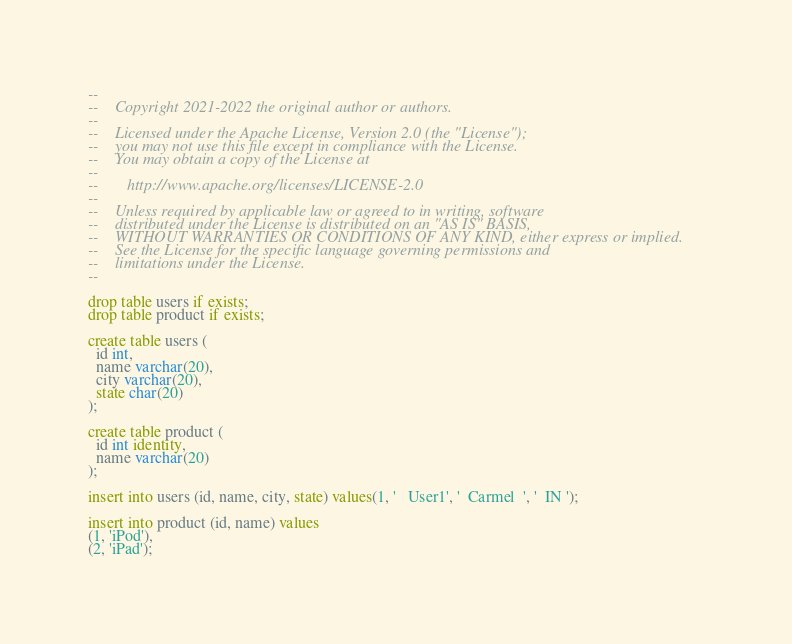<code> <loc_0><loc_0><loc_500><loc_500><_SQL_>--
--    Copyright 2021-2022 the original author or authors.
--
--    Licensed under the Apache License, Version 2.0 (the "License");
--    you may not use this file except in compliance with the License.
--    You may obtain a copy of the License at
--
--       http://www.apache.org/licenses/LICENSE-2.0
--
--    Unless required by applicable law or agreed to in writing, software
--    distributed under the License is distributed on an "AS IS" BASIS,
--    WITHOUT WARRANTIES OR CONDITIONS OF ANY KIND, either express or implied.
--    See the License for the specific language governing permissions and
--    limitations under the License.
--

drop table users if exists;
drop table product if exists;

create table users (
  id int,
  name varchar(20),
  city varchar(20),
  state char(20)
);

create table product (
  id int identity,
  name varchar(20)
);

insert into users (id, name, city, state) values(1, '   User1', '  Carmel  ', '  IN ');

insert into product (id, name) values
(1, 'iPod'),
(2, 'iPad');
</code> 